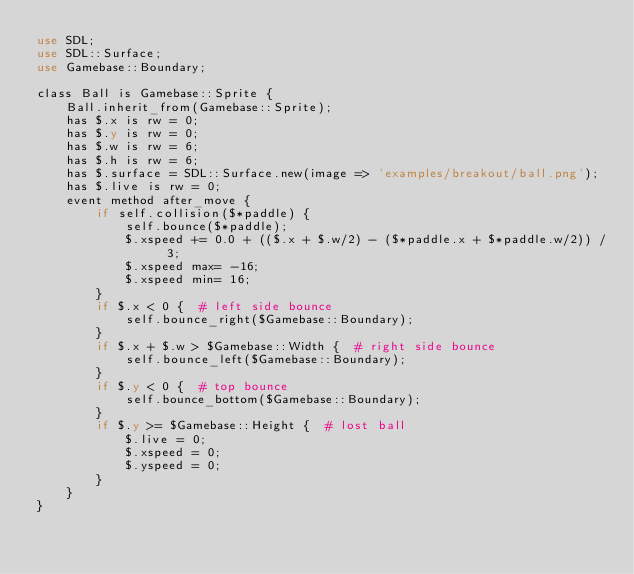<code> <loc_0><loc_0><loc_500><loc_500><_Perl_>use SDL;
use SDL::Surface;
use Gamebase::Boundary;

class Ball is Gamebase::Sprite {
	Ball.inherit_from(Gamebase::Sprite);
	has $.x is rw = 0;
	has $.y is rw = 0;
	has $.w is rw = 6;
	has $.h is rw = 6;
	has $.surface = SDL::Surface.new(image => 'examples/breakout/ball.png');
	has $.live is rw = 0;
	event method after_move {
		if self.collision($*paddle) {
			self.bounce($*paddle);
			$.xspeed += 0.0 + (($.x + $.w/2) - ($*paddle.x + $*paddle.w/2)) / 3;
			$.xspeed max= -16;
			$.xspeed min= 16;
		}
		if $.x < 0 {  # left side bounce
			self.bounce_right($Gamebase::Boundary);
		}
		if $.x + $.w > $Gamebase::Width {  # right side bounce
			self.bounce_left($Gamebase::Boundary);
		}
		if $.y < 0 {  # top bounce
			self.bounce_bottom($Gamebase::Boundary);
		}
		if $.y >= $Gamebase::Height {  # lost ball
			$.live = 0;
			$.xspeed = 0;
			$.yspeed = 0;
		}
	}
}
</code> 